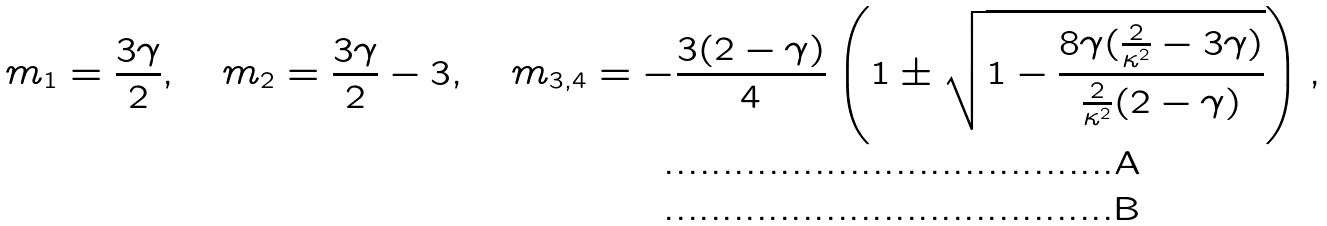Convert formula to latex. <formula><loc_0><loc_0><loc_500><loc_500>m _ { 1 } = \frac { 3 \gamma } { 2 } , \quad m _ { 2 } = \frac { 3 \gamma } { 2 } - 3 , \quad m _ { 3 , 4 } = - \frac { 3 ( 2 - \gamma ) } { 4 } \left ( 1 \pm \sqrt { 1 - \frac { 8 \gamma ( \frac { 2 } { \kappa ^ { 2 } } - 3 \gamma ) } { \frac { 2 } { \kappa ^ { 2 } } ( 2 - \gamma ) } } \right ) , \\</formula> 